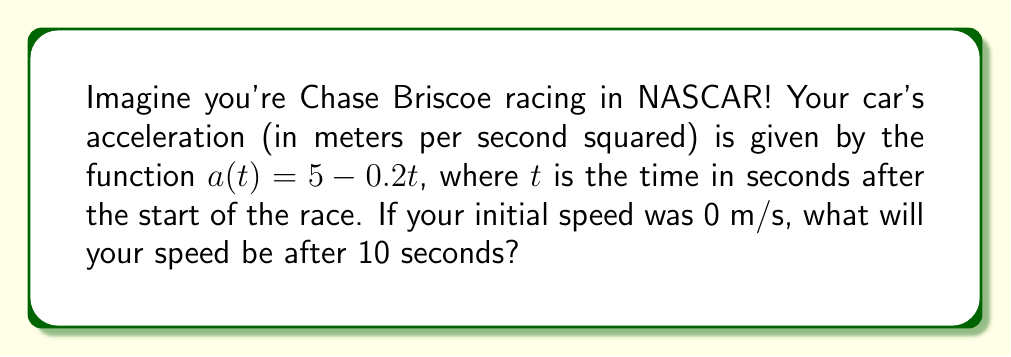Solve this math problem. Let's approach this step-by-step:

1) We know that acceleration is the rate of change of velocity with respect to time. In mathematical terms:

   $$a(t) = \frac{dv}{dt}$$

   where $v$ is velocity and $t$ is time.

2) We're given the acceleration function:

   $$a(t) = 5 - 0.2t$$

3) To find the velocity, we need to integrate the acceleration function:

   $$v(t) = \int a(t) dt = \int (5 - 0.2t) dt$$

4) Integrating this:

   $$v(t) = 5t - 0.1t^2 + C$$

   where $C$ is the constant of integration.

5) We can find $C$ using the initial condition. We're told that the initial speed was 0 m/s, so:

   $$0 = v(0) = 5(0) - 0.1(0)^2 + C$$
   $$0 = C$$

6) So our velocity function is:

   $$v(t) = 5t - 0.1t^2$$

7) To find the speed after 10 seconds, we simply plug in $t = 10$:

   $$v(10) = 5(10) - 0.1(10)^2$$
   $$= 50 - 10 = 40$$

Therefore, after 10 seconds, Chase Briscoe's speed would be 40 m/s.
Answer: 40 m/s 